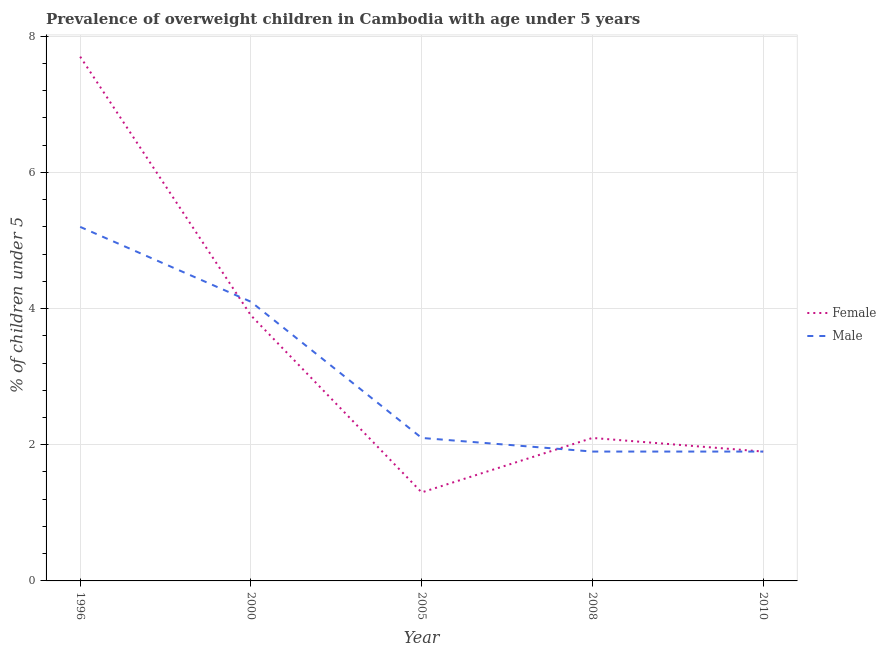Does the line corresponding to percentage of obese male children intersect with the line corresponding to percentage of obese female children?
Give a very brief answer. Yes. Is the number of lines equal to the number of legend labels?
Offer a very short reply. Yes. What is the percentage of obese female children in 1996?
Provide a succinct answer. 7.7. Across all years, what is the maximum percentage of obese male children?
Offer a very short reply. 5.2. Across all years, what is the minimum percentage of obese male children?
Your answer should be very brief. 1.9. In which year was the percentage of obese male children maximum?
Your response must be concise. 1996. What is the total percentage of obese male children in the graph?
Your answer should be very brief. 15.2. What is the difference between the percentage of obese male children in 2008 and that in 2010?
Your answer should be very brief. 0. What is the difference between the percentage of obese female children in 1996 and the percentage of obese male children in 2008?
Ensure brevity in your answer.  5.8. What is the average percentage of obese female children per year?
Offer a very short reply. 3.38. In the year 2005, what is the difference between the percentage of obese male children and percentage of obese female children?
Your answer should be compact. 0.8. In how many years, is the percentage of obese female children greater than 2 %?
Your response must be concise. 3. What is the ratio of the percentage of obese male children in 2000 to that in 2005?
Keep it short and to the point. 1.95. Is the percentage of obese female children in 1996 less than that in 2000?
Your response must be concise. No. Is the difference between the percentage of obese female children in 2008 and 2010 greater than the difference between the percentage of obese male children in 2008 and 2010?
Your answer should be compact. Yes. What is the difference between the highest and the second highest percentage of obese female children?
Your answer should be very brief. 3.8. What is the difference between the highest and the lowest percentage of obese female children?
Your response must be concise. 6.4. In how many years, is the percentage of obese male children greater than the average percentage of obese male children taken over all years?
Make the answer very short. 2. Is the percentage of obese female children strictly greater than the percentage of obese male children over the years?
Make the answer very short. No. Is the percentage of obese female children strictly less than the percentage of obese male children over the years?
Offer a terse response. No. How many lines are there?
Make the answer very short. 2. How many years are there in the graph?
Make the answer very short. 5. What is the difference between two consecutive major ticks on the Y-axis?
Provide a short and direct response. 2. Are the values on the major ticks of Y-axis written in scientific E-notation?
Make the answer very short. No. Does the graph contain any zero values?
Offer a terse response. No. Does the graph contain grids?
Your response must be concise. Yes. Where does the legend appear in the graph?
Provide a succinct answer. Center right. How many legend labels are there?
Your answer should be compact. 2. What is the title of the graph?
Offer a very short reply. Prevalence of overweight children in Cambodia with age under 5 years. What is the label or title of the X-axis?
Provide a short and direct response. Year. What is the label or title of the Y-axis?
Offer a terse response.  % of children under 5. What is the  % of children under 5 in Female in 1996?
Your response must be concise. 7.7. What is the  % of children under 5 of Male in 1996?
Offer a very short reply. 5.2. What is the  % of children under 5 of Female in 2000?
Keep it short and to the point. 3.9. What is the  % of children under 5 in Male in 2000?
Ensure brevity in your answer.  4.1. What is the  % of children under 5 in Female in 2005?
Ensure brevity in your answer.  1.3. What is the  % of children under 5 in Male in 2005?
Offer a very short reply. 2.1. What is the  % of children under 5 of Female in 2008?
Keep it short and to the point. 2.1. What is the  % of children under 5 in Male in 2008?
Your answer should be compact. 1.9. What is the  % of children under 5 in Female in 2010?
Make the answer very short. 1.9. What is the  % of children under 5 in Male in 2010?
Provide a short and direct response. 1.9. Across all years, what is the maximum  % of children under 5 in Female?
Ensure brevity in your answer.  7.7. Across all years, what is the maximum  % of children under 5 in Male?
Ensure brevity in your answer.  5.2. Across all years, what is the minimum  % of children under 5 in Female?
Make the answer very short. 1.3. Across all years, what is the minimum  % of children under 5 in Male?
Keep it short and to the point. 1.9. What is the total  % of children under 5 of Male in the graph?
Provide a succinct answer. 15.2. What is the difference between the  % of children under 5 in Male in 1996 and that in 2000?
Ensure brevity in your answer.  1.1. What is the difference between the  % of children under 5 in Female in 1996 and that in 2008?
Offer a very short reply. 5.6. What is the difference between the  % of children under 5 in Male in 1996 and that in 2008?
Provide a short and direct response. 3.3. What is the difference between the  % of children under 5 in Female in 1996 and that in 2010?
Offer a terse response. 5.8. What is the difference between the  % of children under 5 of Female in 2000 and that in 2005?
Make the answer very short. 2.6. What is the difference between the  % of children under 5 in Female in 2000 and that in 2008?
Give a very brief answer. 1.8. What is the difference between the  % of children under 5 of Male in 2000 and that in 2010?
Keep it short and to the point. 2.2. What is the difference between the  % of children under 5 of Female in 2005 and that in 2008?
Provide a succinct answer. -0.8. What is the difference between the  % of children under 5 of Female in 2005 and that in 2010?
Your answer should be very brief. -0.6. What is the difference between the  % of children under 5 of Male in 2005 and that in 2010?
Provide a short and direct response. 0.2. What is the difference between the  % of children under 5 of Male in 2008 and that in 2010?
Your answer should be very brief. 0. What is the difference between the  % of children under 5 of Female in 1996 and the  % of children under 5 of Male in 2005?
Provide a succinct answer. 5.6. What is the difference between the  % of children under 5 in Female in 1996 and the  % of children under 5 in Male in 2010?
Your answer should be very brief. 5.8. What is the difference between the  % of children under 5 of Female in 2000 and the  % of children under 5 of Male in 2008?
Offer a very short reply. 2. What is the difference between the  % of children under 5 of Female in 2000 and the  % of children under 5 of Male in 2010?
Provide a short and direct response. 2. What is the difference between the  % of children under 5 of Female in 2005 and the  % of children under 5 of Male in 2010?
Give a very brief answer. -0.6. What is the difference between the  % of children under 5 in Female in 2008 and the  % of children under 5 in Male in 2010?
Offer a terse response. 0.2. What is the average  % of children under 5 in Female per year?
Keep it short and to the point. 3.38. What is the average  % of children under 5 of Male per year?
Offer a terse response. 3.04. In the year 2008, what is the difference between the  % of children under 5 in Female and  % of children under 5 in Male?
Make the answer very short. 0.2. In the year 2010, what is the difference between the  % of children under 5 in Female and  % of children under 5 in Male?
Ensure brevity in your answer.  0. What is the ratio of the  % of children under 5 in Female in 1996 to that in 2000?
Give a very brief answer. 1.97. What is the ratio of the  % of children under 5 of Male in 1996 to that in 2000?
Give a very brief answer. 1.27. What is the ratio of the  % of children under 5 of Female in 1996 to that in 2005?
Provide a succinct answer. 5.92. What is the ratio of the  % of children under 5 of Male in 1996 to that in 2005?
Ensure brevity in your answer.  2.48. What is the ratio of the  % of children under 5 of Female in 1996 to that in 2008?
Offer a terse response. 3.67. What is the ratio of the  % of children under 5 of Male in 1996 to that in 2008?
Your answer should be compact. 2.74. What is the ratio of the  % of children under 5 in Female in 1996 to that in 2010?
Keep it short and to the point. 4.05. What is the ratio of the  % of children under 5 in Male in 1996 to that in 2010?
Make the answer very short. 2.74. What is the ratio of the  % of children under 5 of Female in 2000 to that in 2005?
Your answer should be compact. 3. What is the ratio of the  % of children under 5 in Male in 2000 to that in 2005?
Give a very brief answer. 1.95. What is the ratio of the  % of children under 5 in Female in 2000 to that in 2008?
Keep it short and to the point. 1.86. What is the ratio of the  % of children under 5 of Male in 2000 to that in 2008?
Make the answer very short. 2.16. What is the ratio of the  % of children under 5 in Female in 2000 to that in 2010?
Your answer should be very brief. 2.05. What is the ratio of the  % of children under 5 in Male in 2000 to that in 2010?
Provide a short and direct response. 2.16. What is the ratio of the  % of children under 5 of Female in 2005 to that in 2008?
Your response must be concise. 0.62. What is the ratio of the  % of children under 5 in Male in 2005 to that in 2008?
Your answer should be compact. 1.11. What is the ratio of the  % of children under 5 in Female in 2005 to that in 2010?
Offer a terse response. 0.68. What is the ratio of the  % of children under 5 of Male in 2005 to that in 2010?
Your answer should be compact. 1.11. What is the ratio of the  % of children under 5 in Female in 2008 to that in 2010?
Keep it short and to the point. 1.11. What is the ratio of the  % of children under 5 of Male in 2008 to that in 2010?
Offer a very short reply. 1. What is the difference between the highest and the second highest  % of children under 5 in Female?
Provide a short and direct response. 3.8. What is the difference between the highest and the second highest  % of children under 5 in Male?
Provide a short and direct response. 1.1. 